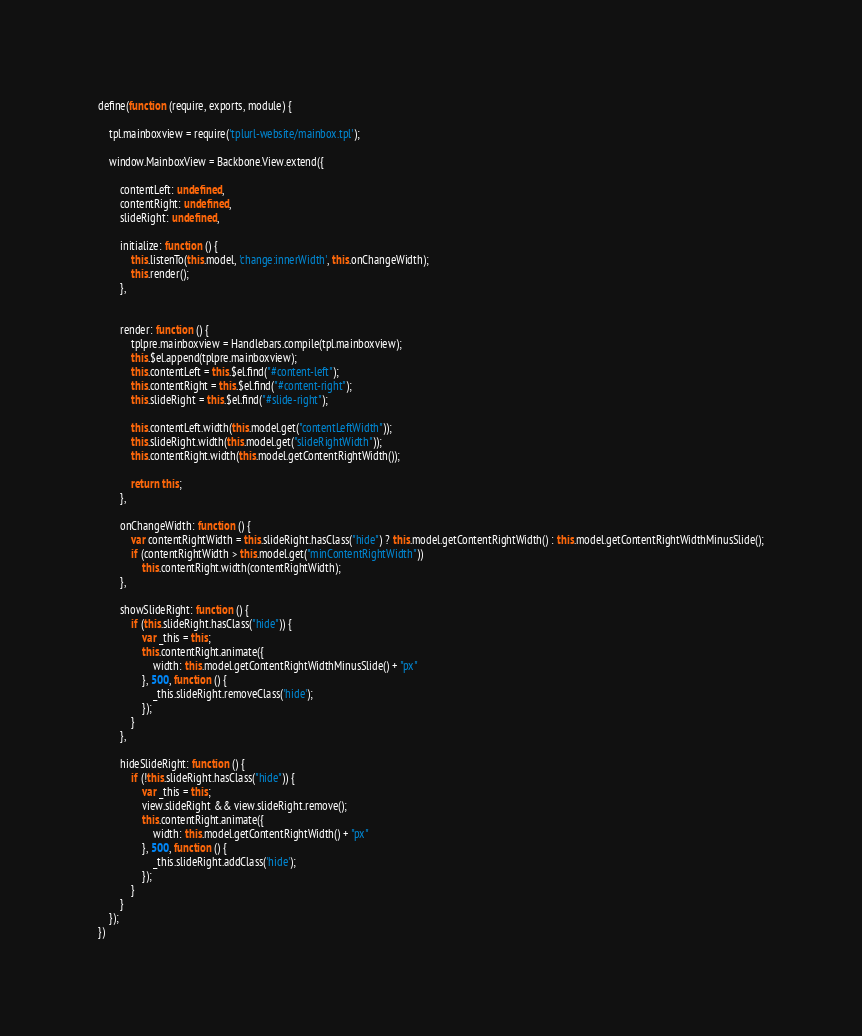Convert code to text. <code><loc_0><loc_0><loc_500><loc_500><_JavaScript_>define(function (require, exports, module) {

    tpl.mainboxview = require('tplurl-website/mainbox.tpl');

    window.MainboxView = Backbone.View.extend({

        contentLeft: undefined,
        contentRight: undefined,
        slideRight: undefined,

        initialize: function () {
            this.listenTo(this.model, 'change:innerWidth', this.onChangeWidth);
            this.render();
        },


        render: function () {
            tplpre.mainboxview = Handlebars.compile(tpl.mainboxview);
            this.$el.append(tplpre.mainboxview);
            this.contentLeft = this.$el.find("#content-left");
            this.contentRight = this.$el.find("#content-right");
            this.slideRight = this.$el.find("#slide-right");

            this.contentLeft.width(this.model.get("contentLeftWidth"));
            this.slideRight.width(this.model.get("slideRightWidth"));
            this.contentRight.width(this.model.getContentRightWidth());

            return this;
        },

        onChangeWidth: function () {
            var contentRightWidth = this.slideRight.hasClass("hide") ? this.model.getContentRightWidth() : this.model.getContentRightWidthMinusSlide();
            if (contentRightWidth > this.model.get("minContentRightWidth"))
                this.contentRight.width(contentRightWidth);
        },

        showSlideRight: function () {
            if (this.slideRight.hasClass("hide")) {
                var _this = this;
                this.contentRight.animate({
                    width: this.model.getContentRightWidthMinusSlide() + "px"
                }, 500, function () {
                    _this.slideRight.removeClass('hide');
                });
            }
        },

        hideSlideRight: function () {
            if (!this.slideRight.hasClass("hide")) {
                var _this = this;
                view.slideRight && view.slideRight.remove();
                this.contentRight.animate({
                    width: this.model.getContentRightWidth() + "px"
                }, 500, function () {
                    _this.slideRight.addClass('hide');
                });
            }
        }
    });
})</code> 